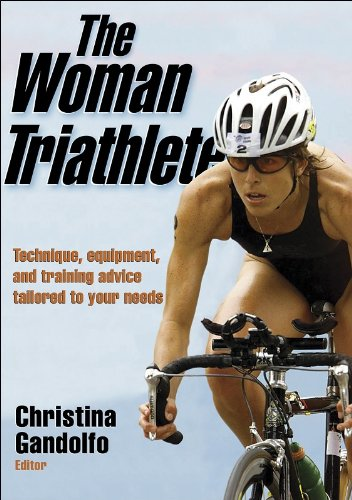What does the cover of the book suggest about the target audience? The cover of 'The Woman Triathlete' shows a dedicated female athlete in action during a triathlon, highlighting that the book's target audience likely consists of female athletes interested in triathlon, who seek comprehensive training and equipment advice. 